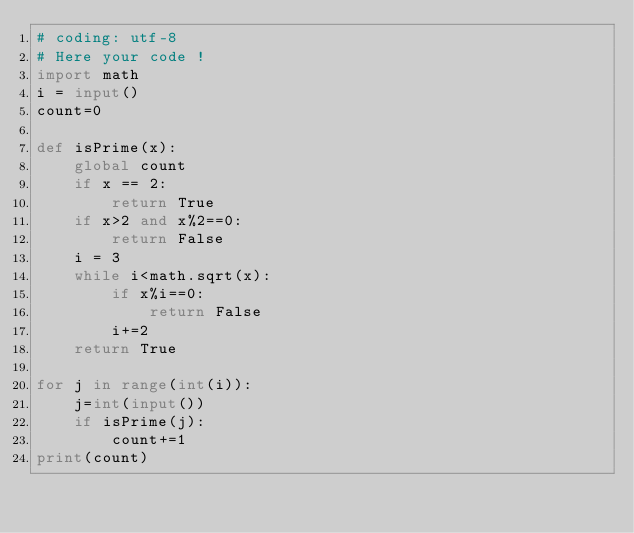Convert code to text. <code><loc_0><loc_0><loc_500><loc_500><_Python_># coding: utf-8
# Here your code !
import math
i = input()
count=0

def isPrime(x):
    global count
    if x == 2:
        return True
    if x>2 and x%2==0:
        return False
    i = 3
    while i<math.sqrt(x):
        if x%i==0:
            return False
        i+=2
    return True

for j in range(int(i)):
    j=int(input())
    if isPrime(j):
        count+=1
print(count)</code> 